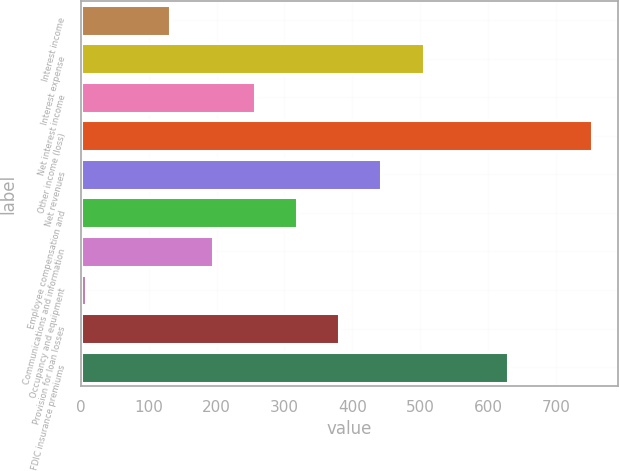Convert chart to OTSL. <chart><loc_0><loc_0><loc_500><loc_500><bar_chart><fcel>Interest income<fcel>Interest expense<fcel>Net interest income<fcel>Other income (loss)<fcel>Net revenues<fcel>Employee compensation and<fcel>Communications and information<fcel>Occupancy and equipment<fcel>Provision for loan losses<fcel>FDIC insurance premiums<nl><fcel>132.2<fcel>504.8<fcel>256.4<fcel>753.2<fcel>442.7<fcel>318.5<fcel>194.3<fcel>8<fcel>380.6<fcel>629<nl></chart> 